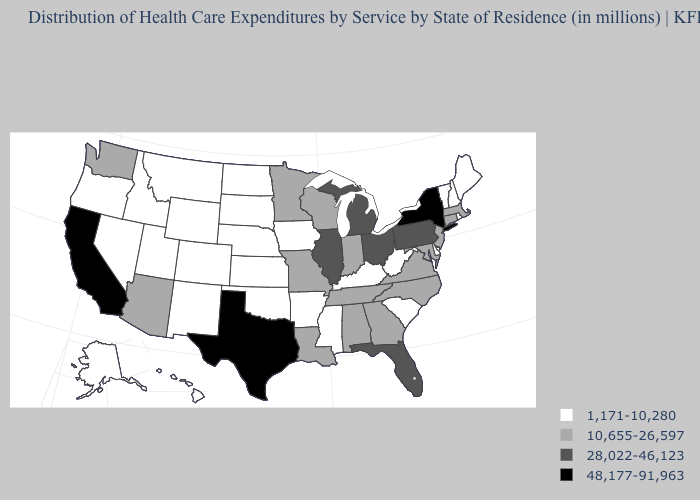Name the states that have a value in the range 10,655-26,597?
Write a very short answer. Alabama, Arizona, Connecticut, Georgia, Indiana, Louisiana, Maryland, Massachusetts, Minnesota, Missouri, New Jersey, North Carolina, Tennessee, Virginia, Washington, Wisconsin. Among the states that border New Jersey , which have the highest value?
Keep it brief. New York. What is the value of Washington?
Quick response, please. 10,655-26,597. What is the lowest value in the South?
Answer briefly. 1,171-10,280. Which states have the highest value in the USA?
Answer briefly. California, New York, Texas. What is the highest value in the MidWest ?
Quick response, please. 28,022-46,123. Among the states that border New Mexico , does Texas have the highest value?
Keep it brief. Yes. Name the states that have a value in the range 48,177-91,963?
Concise answer only. California, New York, Texas. What is the value of Wisconsin?
Concise answer only. 10,655-26,597. Among the states that border New Jersey , which have the lowest value?
Give a very brief answer. Delaware. Is the legend a continuous bar?
Keep it brief. No. Does Nevada have the lowest value in the West?
Concise answer only. Yes. Name the states that have a value in the range 48,177-91,963?
Answer briefly. California, New York, Texas. What is the value of Nebraska?
Write a very short answer. 1,171-10,280. Name the states that have a value in the range 48,177-91,963?
Quick response, please. California, New York, Texas. 